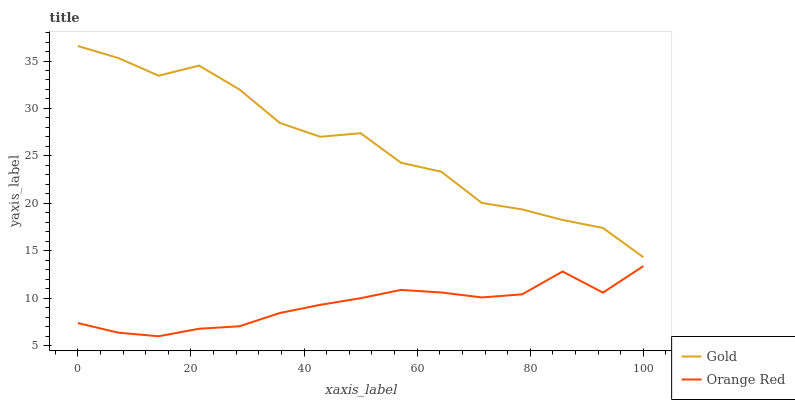Does Orange Red have the minimum area under the curve?
Answer yes or no. Yes. Does Gold have the maximum area under the curve?
Answer yes or no. Yes. Does Gold have the minimum area under the curve?
Answer yes or no. No. Is Orange Red the smoothest?
Answer yes or no. Yes. Is Gold the roughest?
Answer yes or no. Yes. Is Gold the smoothest?
Answer yes or no. No. Does Orange Red have the lowest value?
Answer yes or no. Yes. Does Gold have the lowest value?
Answer yes or no. No. Does Gold have the highest value?
Answer yes or no. Yes. Is Orange Red less than Gold?
Answer yes or no. Yes. Is Gold greater than Orange Red?
Answer yes or no. Yes. Does Orange Red intersect Gold?
Answer yes or no. No. 